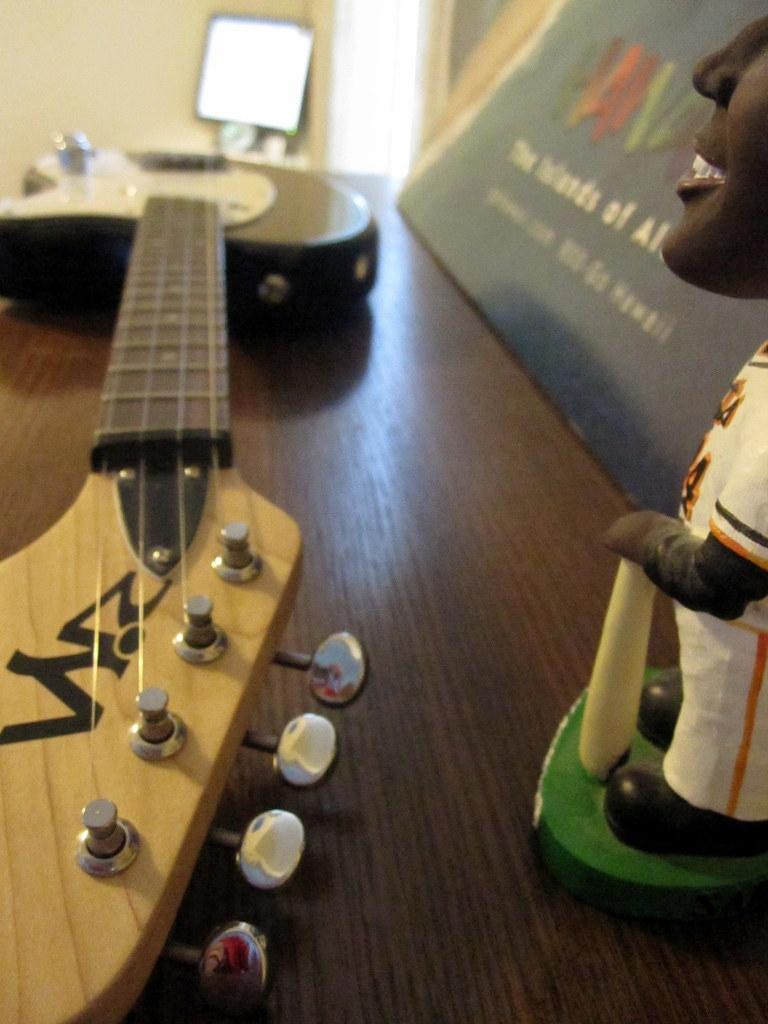What musical instrument is visible in the image? There is a guitar in the image. What type of artwork is present in the image? There is a sculpture in the image. What is written or displayed on a board in the image? There is a board with text in the image. Where is the board with text located? The board is on a table in the image. What can be seen in the background of the image? There is an object in the background of the image. Can you tell me how much honey is being used in the sculpture? There is no honey present in the image, as it features a guitar, a sculpture, a board with text, and an object in the background. 